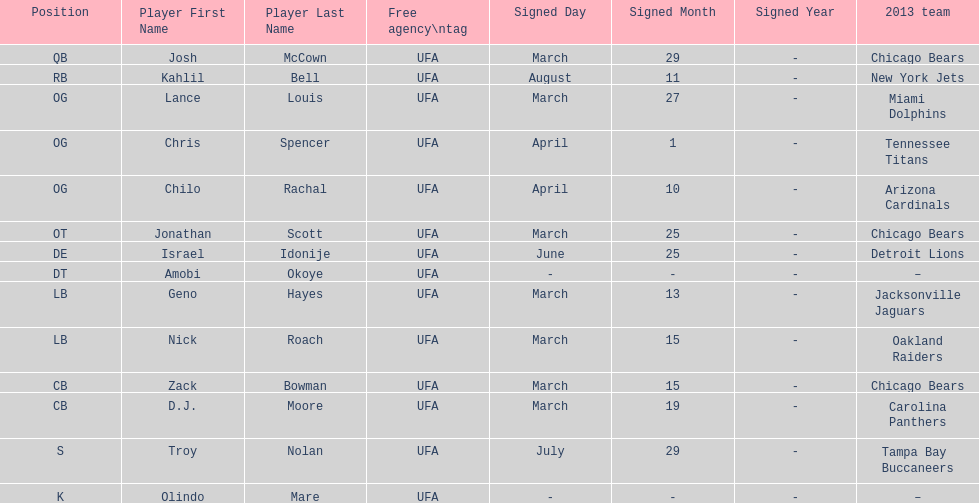His/her first name is the same name as a country. Israel Idonije. 